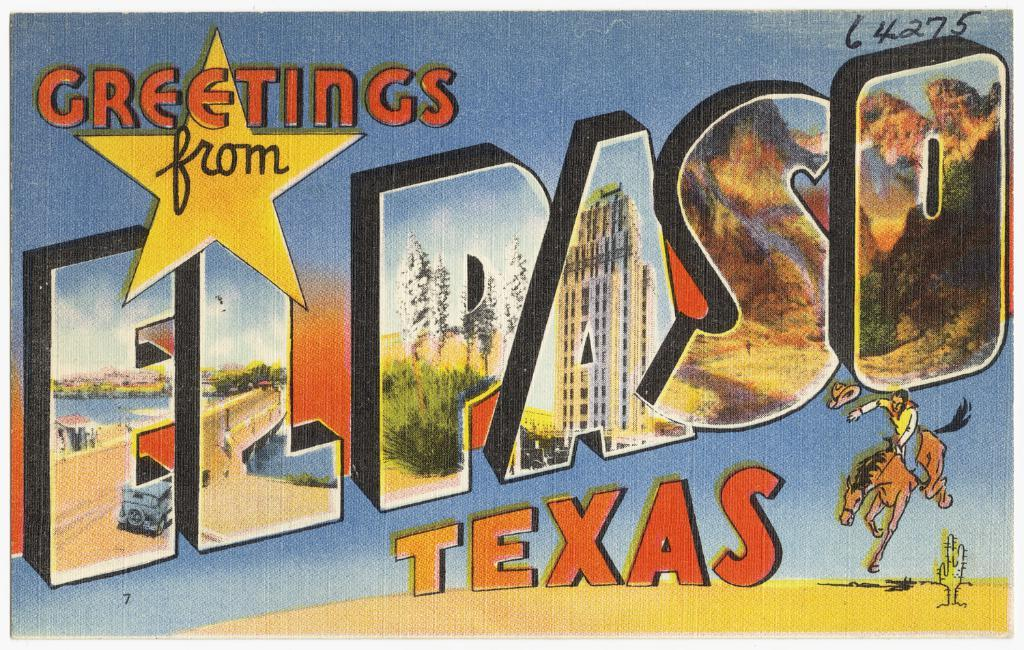<image>
Write a terse but informative summary of the picture. A postcard is for visitors of El Paso Texas. 